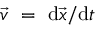<formula> <loc_0><loc_0><loc_500><loc_500>{ \vec { v } = { d } { \vec { x } } / { d } t</formula> 